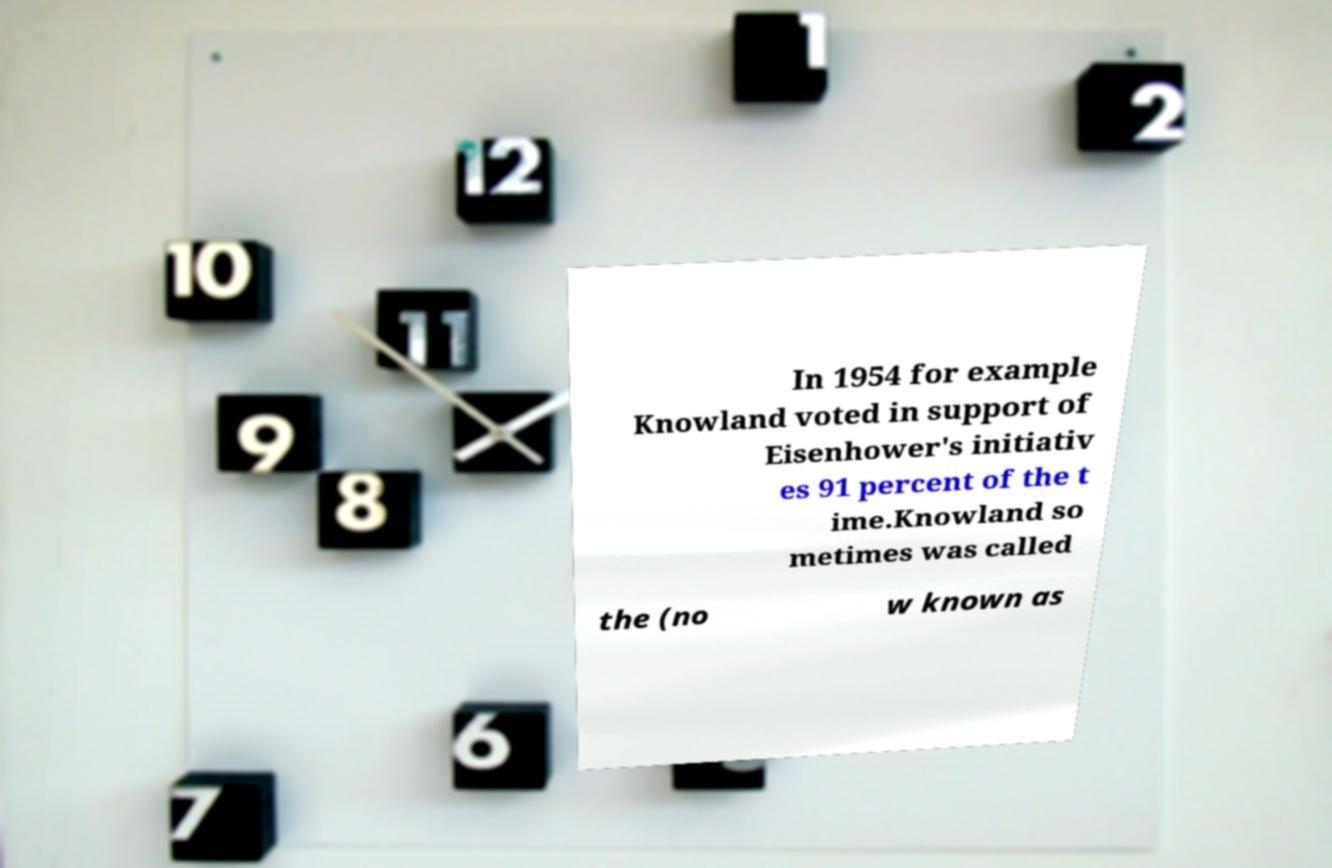Can you read and provide the text displayed in the image?This photo seems to have some interesting text. Can you extract and type it out for me? In 1954 for example Knowland voted in support of Eisenhower's initiativ es 91 percent of the t ime.Knowland so metimes was called the (no w known as 